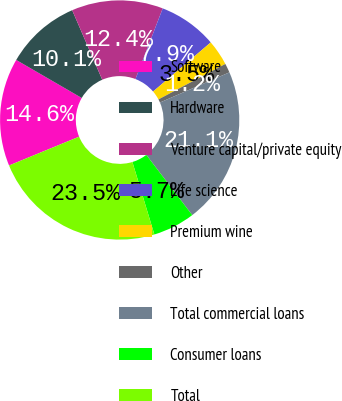<chart> <loc_0><loc_0><loc_500><loc_500><pie_chart><fcel>Software<fcel>Hardware<fcel>Venture capital/private equity<fcel>Life science<fcel>Premium wine<fcel>Other<fcel>Total commercial loans<fcel>Consumer loans<fcel>Total<nl><fcel>14.58%<fcel>10.13%<fcel>12.36%<fcel>7.91%<fcel>3.47%<fcel>1.24%<fcel>21.15%<fcel>5.69%<fcel>23.47%<nl></chart> 